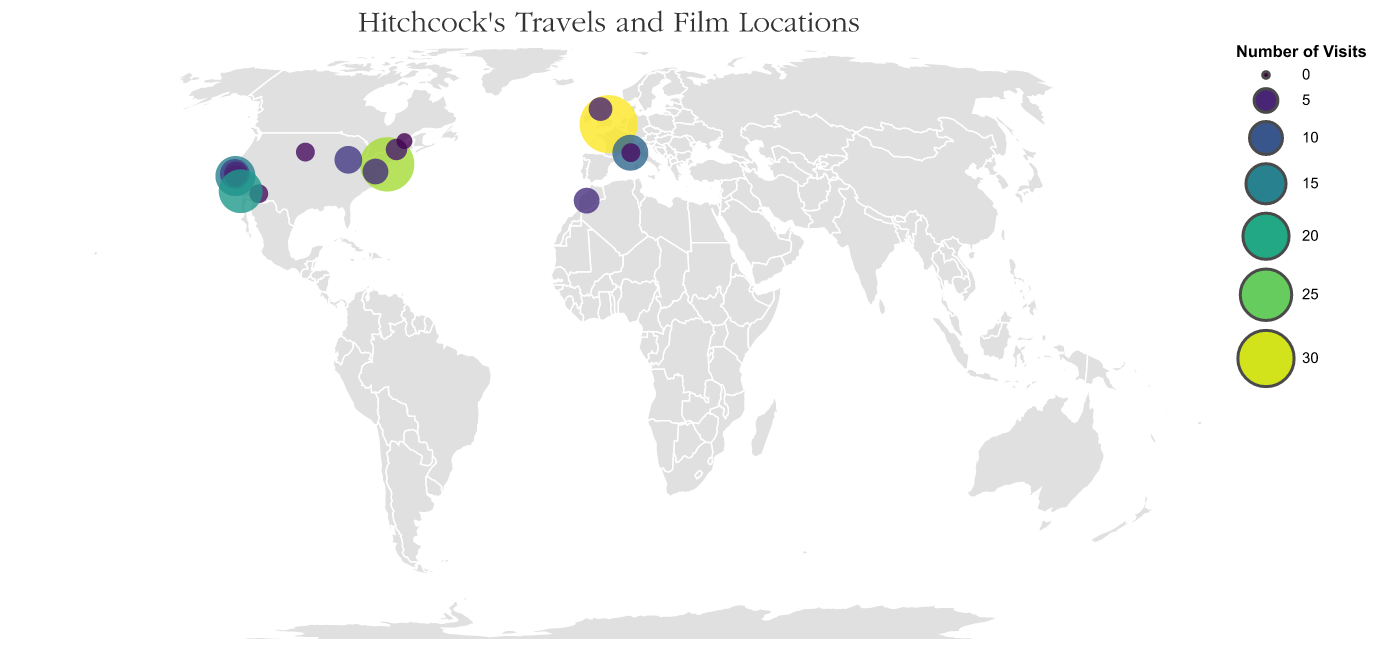What is the location with the highest number of visits by Hitchcock? By examining the size and color of the circles on the plot, we can identify the largest and darkest circle, which represents the location with the highest number of visits.
Answer: London Which locations did Hitchcock visit more frequently, New York City or San Francisco? Compare the sizes and colors of the circles representing New York City and San Francisco on the plot. New York City's circle is larger and more vibrant, indicating higher frequency.
Answer: New York City How many locations did Hitchcock visit at least 10 times? Count the circles with sizes and colors indicating a minimum of 10 visits. The locations that fulfill this criterion are London, New York City, San Francisco, Los Angeles, and French Riviera.
Answer: 5 What connection can you draw between the number of visits and the number of films influenced by these visits? Examine the data points: Locations with higher visits tend to have influenced multiple films. For example, London, with 32 visits, influenced three films, While smaller circles show fewer films influenced.
Answer: More visits often correlate with more films Which location did Hitchcock visit more frequently, French Riviera or Morocco? Compare both circles based on their size and color. The French Riviera has a larger and more vibrant circle than Morocco, indicating a higher number of visits.
Answer: French Riviera What's the total number of locations Hitchcock visited with visits less than 5 times? Count the circles representing locations with fewer than 5 visits (Vermont, Mount Rushmore, Quebec City, Monaco, Phoenix).
Answer: 5 How does the visit frequency to California (Los Angeles, San Francisco, Santa Rosa) compare to the total visits in New York City? Sum the visits to California locations (18 Los Angeles + 15 San Francisco + 5 Santa Rosa = 38) and compare with New York City's visits (28). California has more total visits.
Answer: California has more total visits Identify the locations outside North America that influenced Hitchcock's films and received more than 5 visits. Examine the plot focusing on circles outside North America with more than 5 visits: London (Europe) and French Riviera (Europe) are the identified locations.
Answer: London; French Riviera Which specific film locations are represented in the plot that were influenced by fewer than 5 visits? Identify circles with fewer than 5 visits and check the corresponding influences: Quebec City (I Confess), Monaco (To Catch a Thief), Phoenix (Psycho), Vermont (The Trouble with Harry), and Mount Rushmore (North by Northwest).
Answer: Quebec City; Monaco; Phoenix; Vermont; Mount Rushmore 